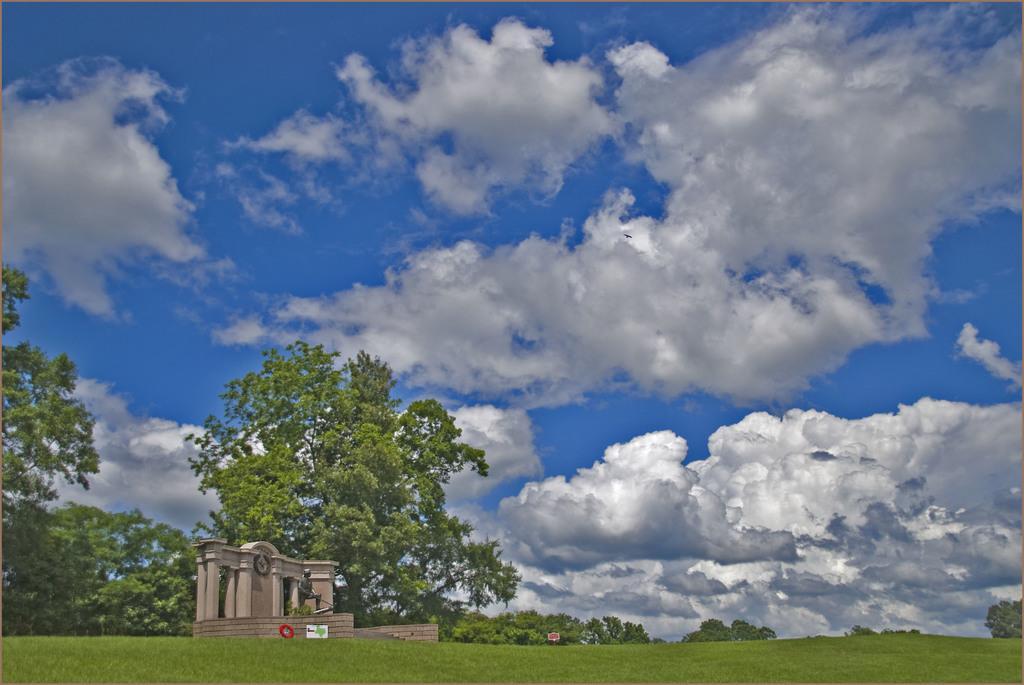Could you give a brief overview of what you see in this image? This picture shows a few trees and we see grass on the ground and a monument and a blue cloudy sky. 